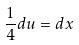<formula> <loc_0><loc_0><loc_500><loc_500>\frac { 1 } { 4 } d u = d x</formula> 